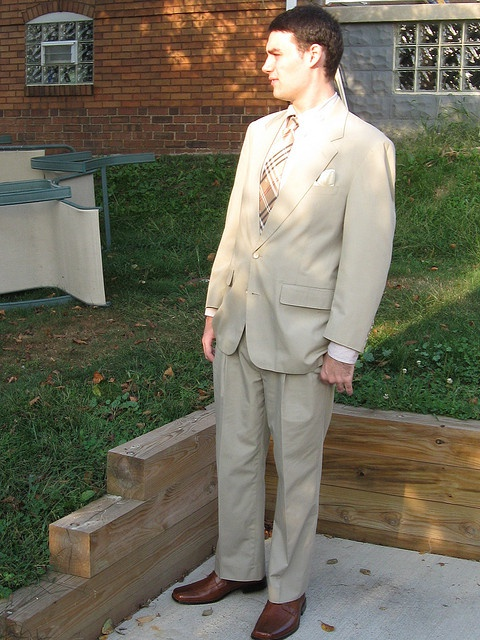Describe the objects in this image and their specific colors. I can see people in black, darkgray, ivory, tan, and gray tones, bench in black, darkgray, gray, and purple tones, and tie in black, ivory, and tan tones in this image. 